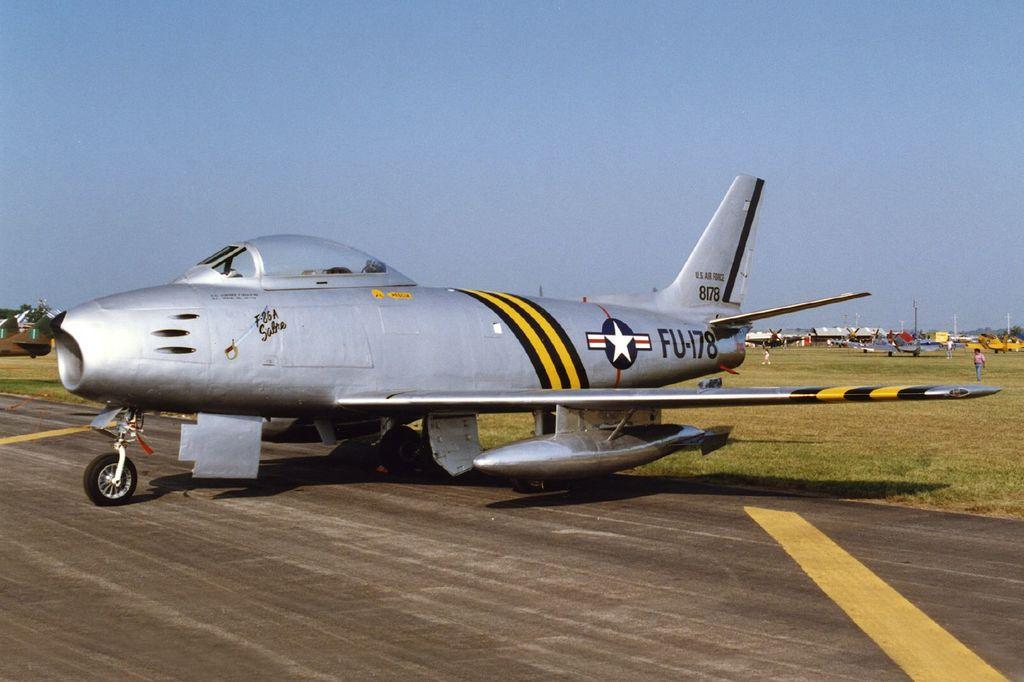What is the number on the plane?
Make the answer very short. Fu-178. 